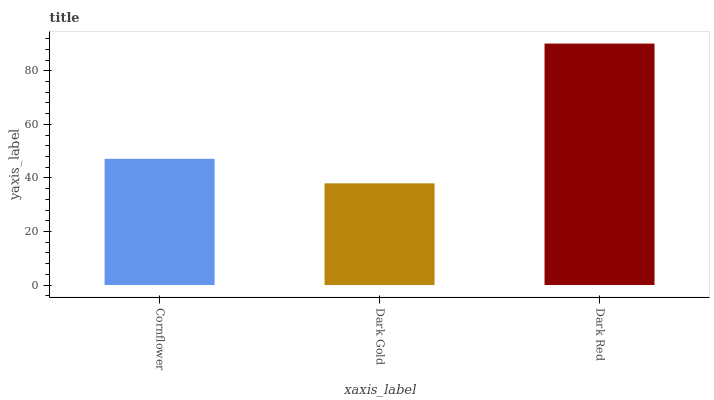Is Dark Gold the minimum?
Answer yes or no. Yes. Is Dark Red the maximum?
Answer yes or no. Yes. Is Dark Red the minimum?
Answer yes or no. No. Is Dark Gold the maximum?
Answer yes or no. No. Is Dark Red greater than Dark Gold?
Answer yes or no. Yes. Is Dark Gold less than Dark Red?
Answer yes or no. Yes. Is Dark Gold greater than Dark Red?
Answer yes or no. No. Is Dark Red less than Dark Gold?
Answer yes or no. No. Is Cornflower the high median?
Answer yes or no. Yes. Is Cornflower the low median?
Answer yes or no. Yes. Is Dark Gold the high median?
Answer yes or no. No. Is Dark Gold the low median?
Answer yes or no. No. 